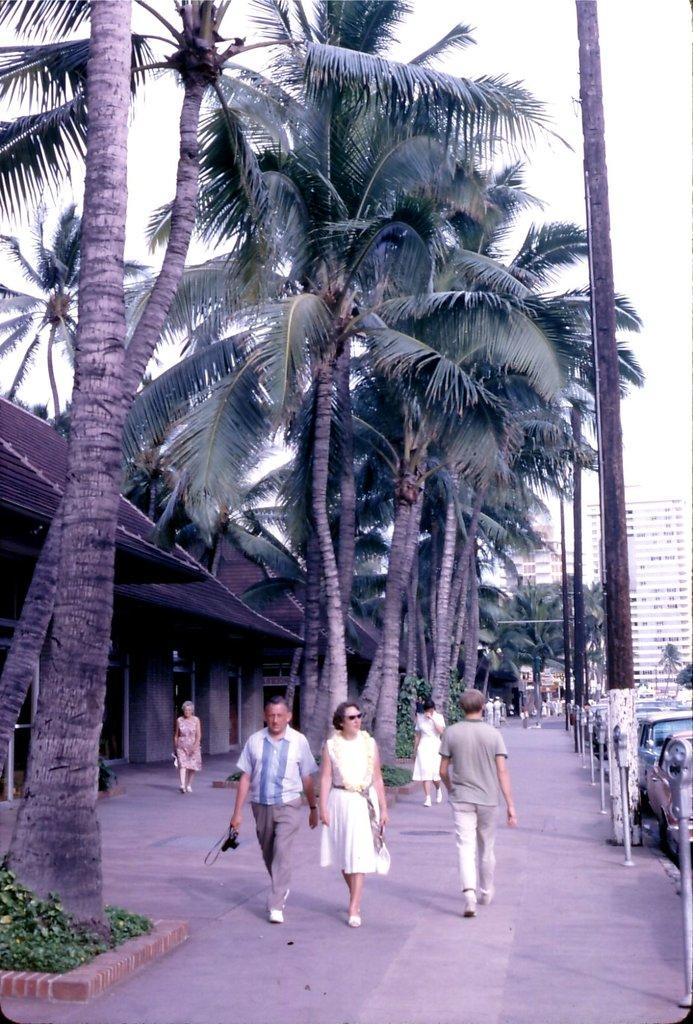What type of structures can be seen in the image? There are houses and buildings in the image. What other elements are present in the image besides structures? There are plants, people walking, cars, trees, and the sky visible in the image. Can you describe the natural elements in the image? There are plants and trees in the image. How many modes of transportation can be seen in the image? There are cars in the image, which is a mode of transportation. What type of coil is being used by the family in the image? There is no family or coil present in the image. How does the tramp interact with the cars in the image? There is no tramp present in the image, and therefore no interaction with the cars can be observed. 